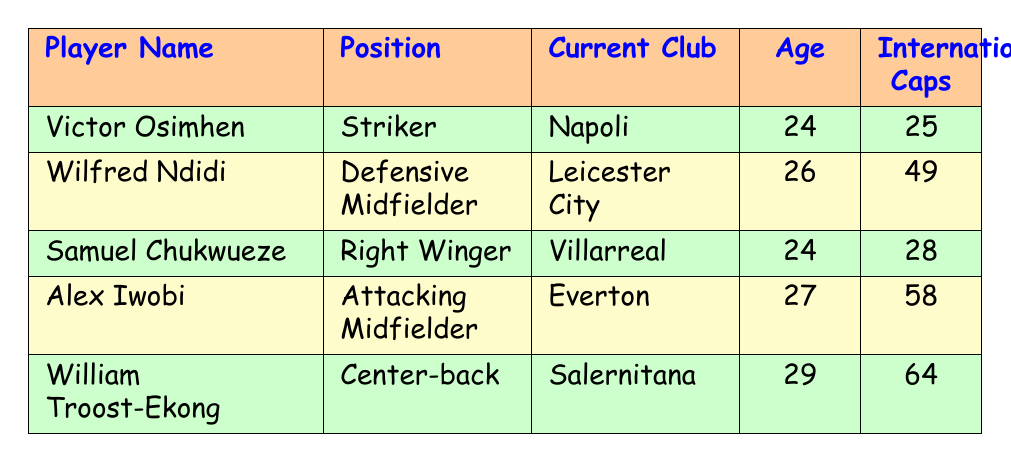What position does Victor Osimhen play? Victor Osimhen is listed in the table under the "Position" column. According to the data, he plays as a Striker.
Answer: Striker How many International Caps does Alex Iwobi have? The table shows that Alex Iwobi's entry indicates he has 58 International Caps. This information is found in the "International Caps" column next to his name.
Answer: 58 Is Wilfred Ndidi older than Samuel Chukwueze? By comparing their ages in the table, Wilfred Ndidi is 26 years old while Samuel Chukwueze is 24 years old. Since 26 is greater than 24, Wilfred Ndidi is indeed older.
Answer: Yes What is the total age of the top 5 players? To find the total age, you add the ages together: 24 (Osimhen) + 26 (Ndidi) + 24 (Chukwueze) + 27 (Iwobi) + 29 (Troost-Ekong) = 130. Therefore, the total age is 130.
Answer: 130 Who has the most International Caps among the players? Looking at the "International Caps" column, William Troost-Ekong has 64 International Caps, which is the highest compared to the other players.
Answer: William Troost-Ekong What position does the player with the least age play? The youngest player is Victor Osimhen, who is 24 years old. Referring to the table, his position is listed as Striker.
Answer: Striker Does Samuel Chukwueze play for a club in the Premier League? Checking the "Current Club" column for Samuel Chukwueze, he plays for Villarreal, which is a club in La Liga, not the Premier League.
Answer: No Which player plays as a Defensive Midfielder and how old is he? From the table, Wilfred Ndidi is the player who plays as a Defensive Midfielder. His age, as listed, is 26 years old.
Answer: Wilfred Ndidi, 26 years old What is the average age of these top 5 players? To find the average age, first add their ages: 24 + 26 + 24 + 27 + 29 = 130. Then, since there are 5 players, divide the total age by 5: 130 / 5 = 26. Therefore, the average age is 26.
Answer: 26 